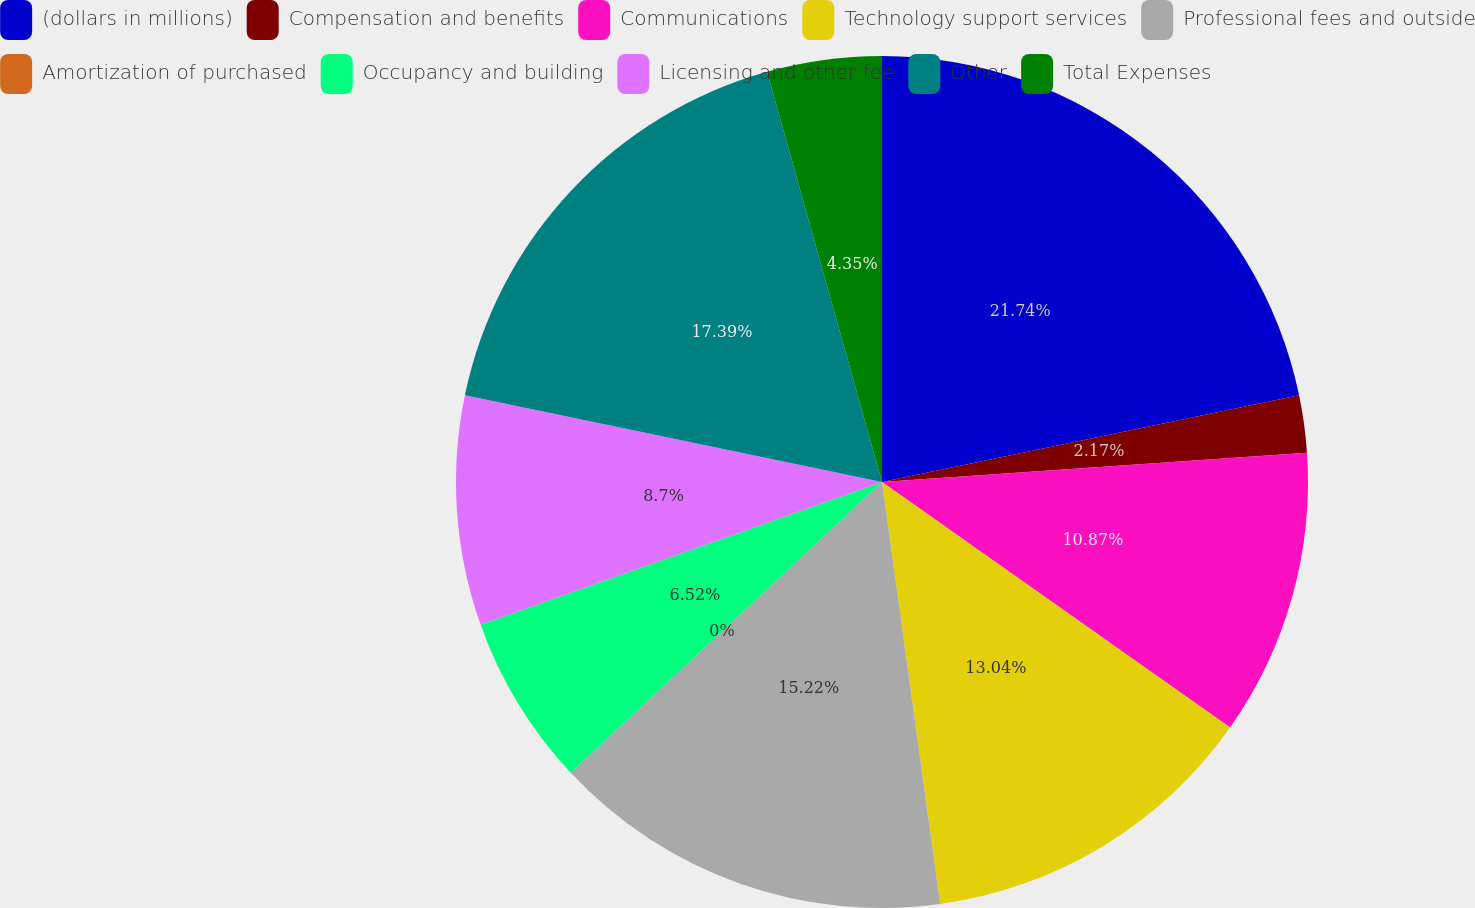Convert chart to OTSL. <chart><loc_0><loc_0><loc_500><loc_500><pie_chart><fcel>(dollars in millions)<fcel>Compensation and benefits<fcel>Communications<fcel>Technology support services<fcel>Professional fees and outside<fcel>Amortization of purchased<fcel>Occupancy and building<fcel>Licensing and other fee<fcel>Other<fcel>Total Expenses<nl><fcel>21.74%<fcel>2.17%<fcel>10.87%<fcel>13.04%<fcel>15.22%<fcel>0.0%<fcel>6.52%<fcel>8.7%<fcel>17.39%<fcel>4.35%<nl></chart> 